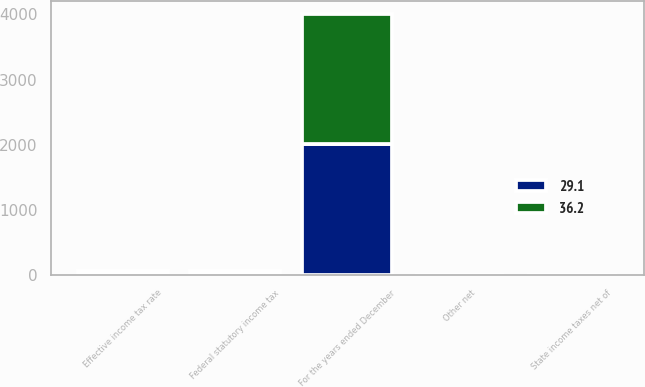Convert chart. <chart><loc_0><loc_0><loc_500><loc_500><stacked_bar_chart><ecel><fcel>For the years ended December<fcel>Federal statutory income tax<fcel>State income taxes net of<fcel>Other net<fcel>Effective income tax rate<nl><fcel>29.1<fcel>2006<fcel>35<fcel>2.8<fcel>0.7<fcel>36.2<nl><fcel>36.2<fcel>2004<fcel>35<fcel>2.6<fcel>0.8<fcel>29.1<nl></chart> 